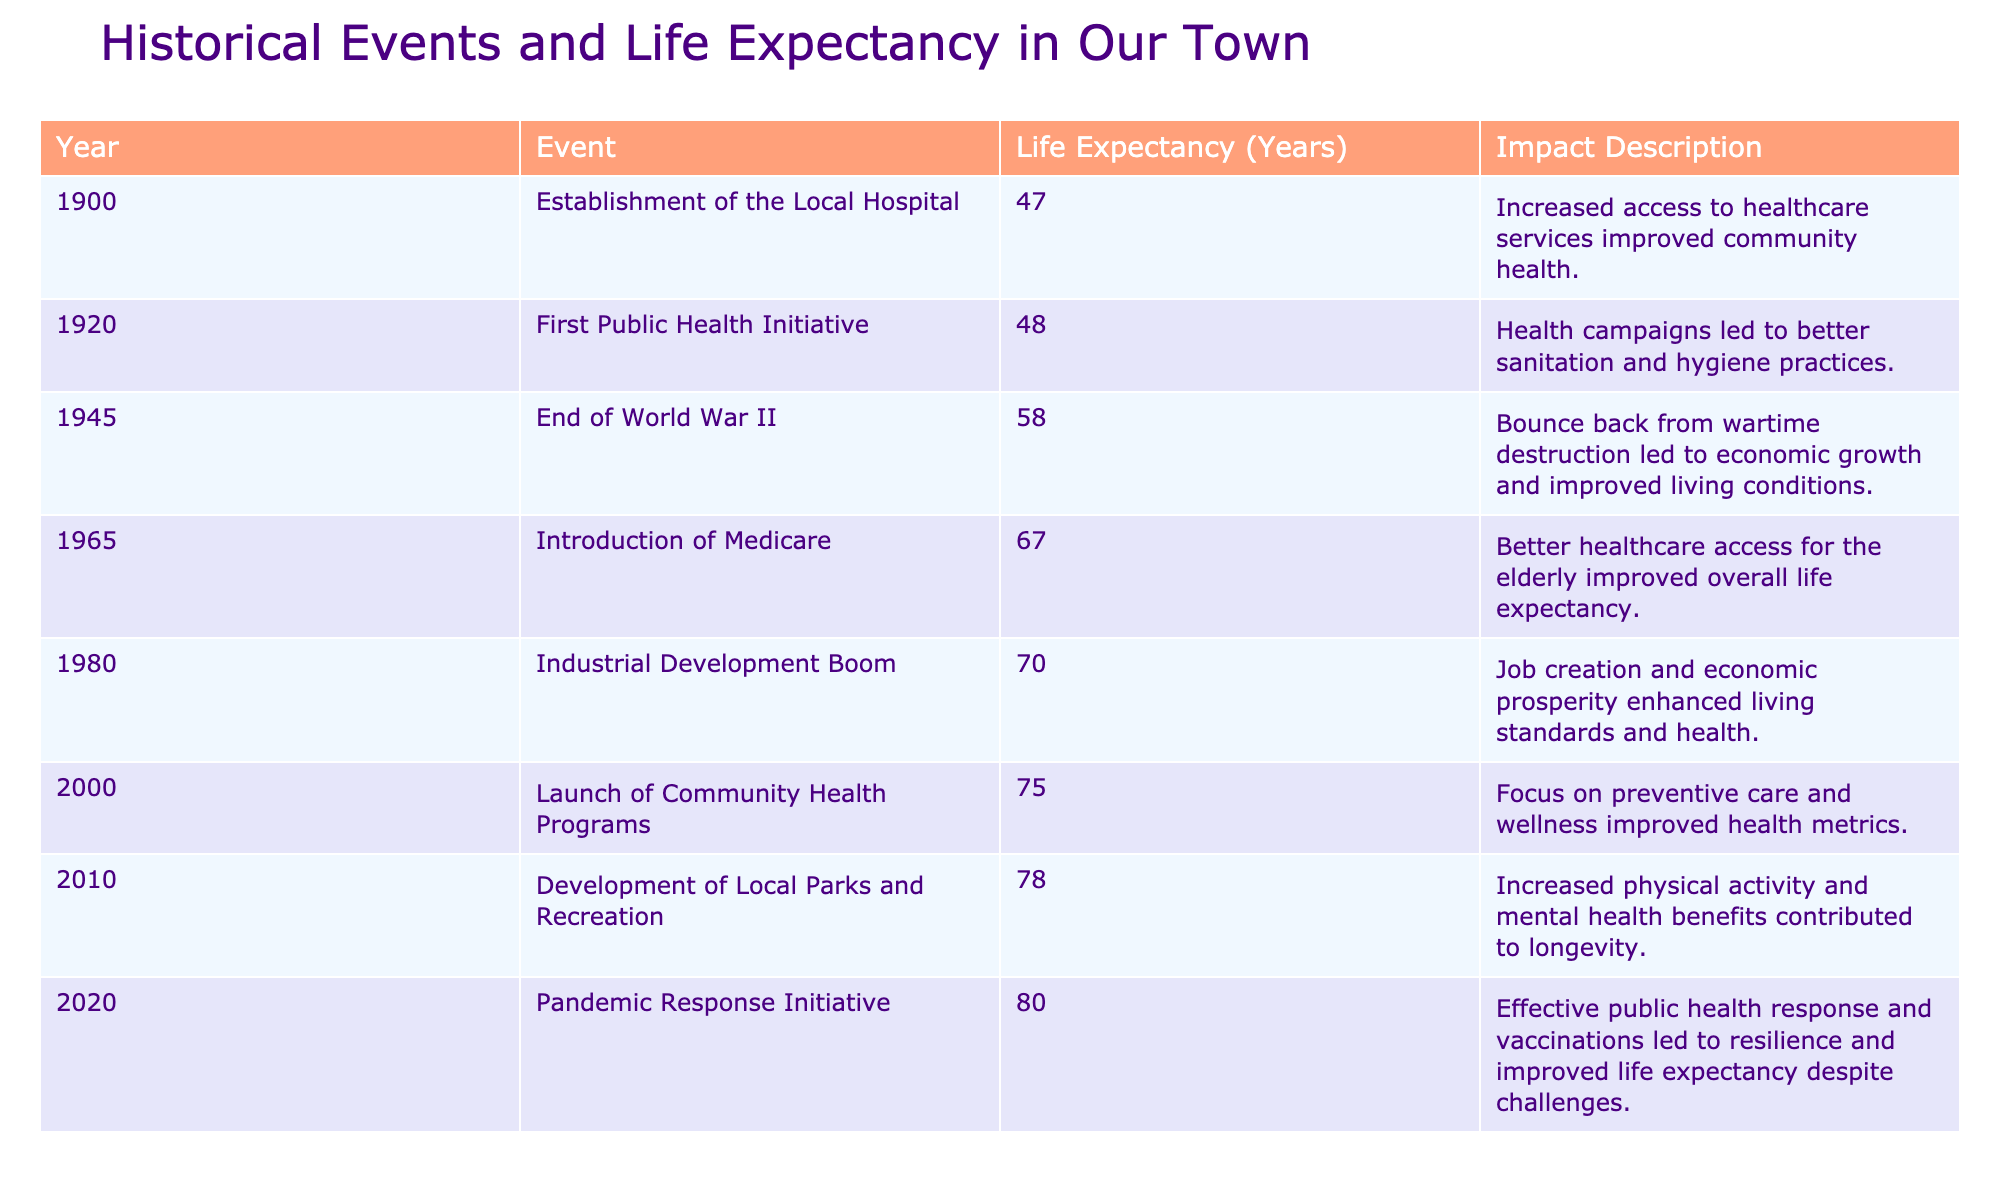What was the life expectancy in 1900? The table shows that the life expectancy in 1900 was 47 years.
Answer: 47 years What major event led to an increase in life expectancy from 1945 to 1965? Between 1945 and 1965, the introduction of Medicare significantly improved healthcare access for the elderly, contributing to an increase in life expectancy.
Answer: Introduction of Medicare How much did life expectancy increase from 1980 to 2000? The life expectancy in 1980 was 70 years and in 2000 it was 75 years, so the increase is calculated as 75 - 70 = 5 years.
Answer: 5 years Is the life expectancy higher in 2020 compared to 2000? Yes, the life expectancy in 2020 was 80 years, which is higher than the 75 years in 2000.
Answer: Yes What was the average life expectancy from 1900 to 2010? To find the average, sum the life expectancies (47 + 48 + 58 + 67 + 70 + 75 + 78) = 443 for 7 events. The average is 443 / 7 = approximately 63.29.
Answer: Approximately 63.29 years Which event had the greatest impact on life expectancy? The event with the greatest life expectancy recorded is the Pandemic Response Initiative in 2020, which reached 80 years.
Answer: Pandemic Response Initiative in 2020 Was there any event that decreased life expectancy in the table? No, each recorded event either increased or maintained life expectancy.
Answer: No What is the difference in life expectancy between the year the local hospital was established and the first public health initiative? The life expectancy in 1900 was 47 years and in 1920 it was 48 years. The difference is 48 - 47 = 1 year.
Answer: 1 year How did the life expectancy trend from 1900 to 2020? The trend shows a steady increase in life expectancy from 47 years in 1900 to 80 years in 2020, indicating significant health improvements over time.
Answer: Steady increase 